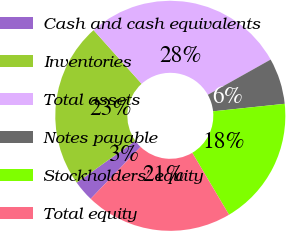Convert chart. <chart><loc_0><loc_0><loc_500><loc_500><pie_chart><fcel>Cash and cash equivalents<fcel>Inventories<fcel>Total assets<fcel>Notes payable<fcel>Stockholders' equity<fcel>Total equity<nl><fcel>2.97%<fcel>23.24%<fcel>28.49%<fcel>6.47%<fcel>18.14%<fcel>20.69%<nl></chart> 